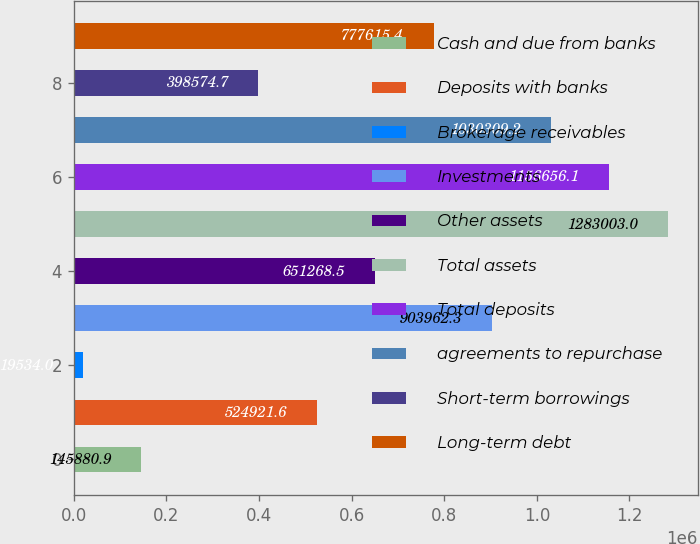Convert chart. <chart><loc_0><loc_0><loc_500><loc_500><bar_chart><fcel>Cash and due from banks<fcel>Deposits with banks<fcel>Brokerage receivables<fcel>Investments<fcel>Other assets<fcel>Total assets<fcel>Total deposits<fcel>agreements to repurchase<fcel>Short-term borrowings<fcel>Long-term debt<nl><fcel>145881<fcel>524922<fcel>19534<fcel>903962<fcel>651268<fcel>1.283e+06<fcel>1.15666e+06<fcel>1.03031e+06<fcel>398575<fcel>777615<nl></chart> 